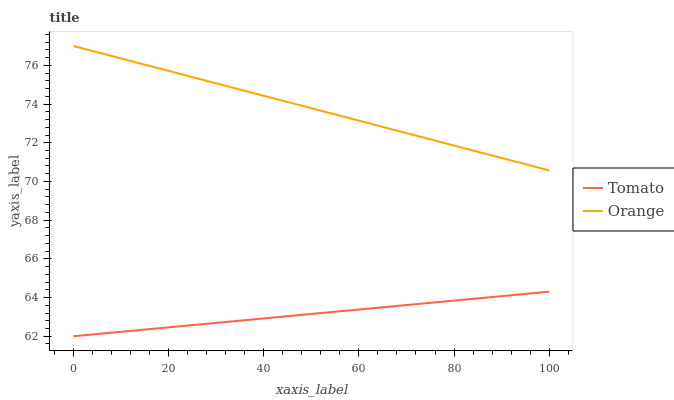Does Orange have the minimum area under the curve?
Answer yes or no. No. Is Orange the smoothest?
Answer yes or no. No. Does Orange have the lowest value?
Answer yes or no. No. Is Tomato less than Orange?
Answer yes or no. Yes. Is Orange greater than Tomato?
Answer yes or no. Yes. Does Tomato intersect Orange?
Answer yes or no. No. 